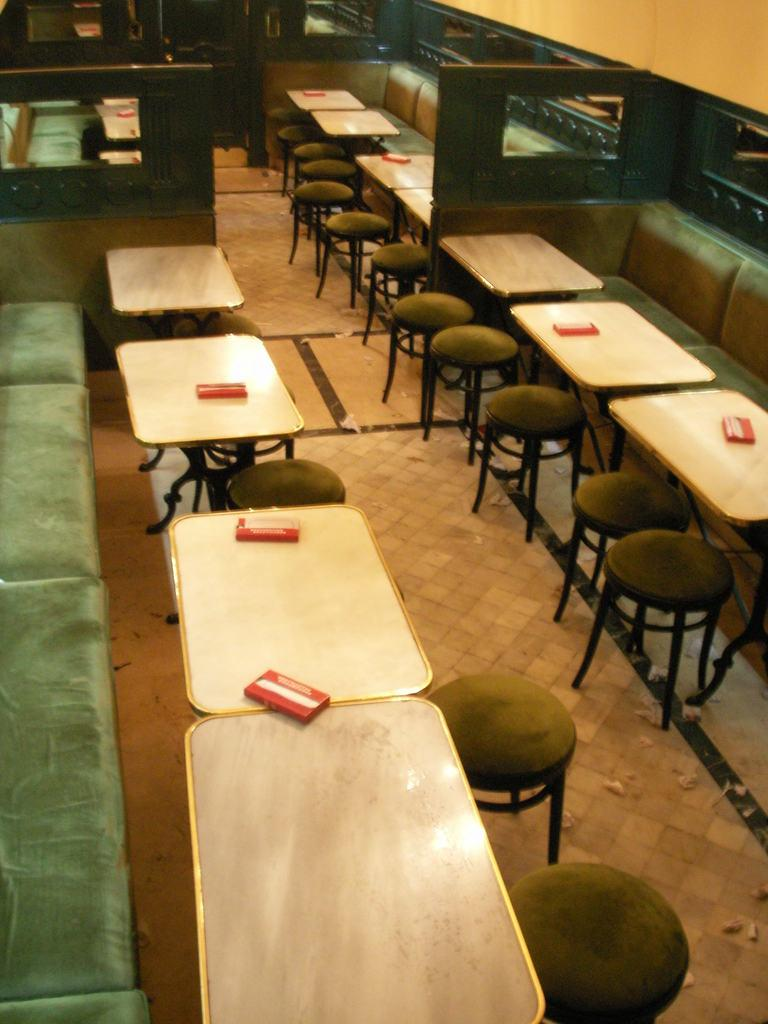What type of furniture is present in the image? There are chairs and sofas in the image. What can be seen on top of the furniture? There are objects on tables in the image. What is the background of the image? There is a wall in the image. What position does the ticket hold in the image? There is no ticket present in the image. How many straws are visible in the image? There are no straws visible in the image. 